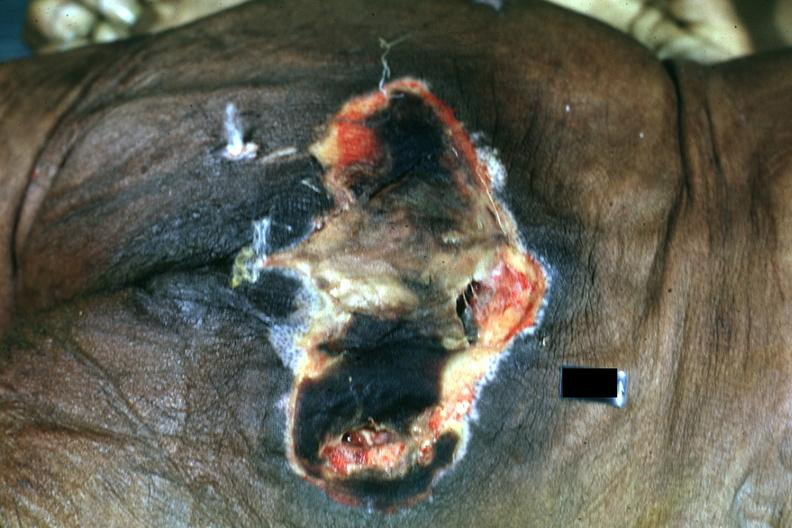does neuronophagia show large necrotic ulcer over sacrum?
Answer the question using a single word or phrase. No 